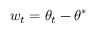Convert formula to latex. <formula><loc_0><loc_0><loc_500><loc_500>w _ { t } = \theta _ { t } - \theta ^ { * }</formula> 